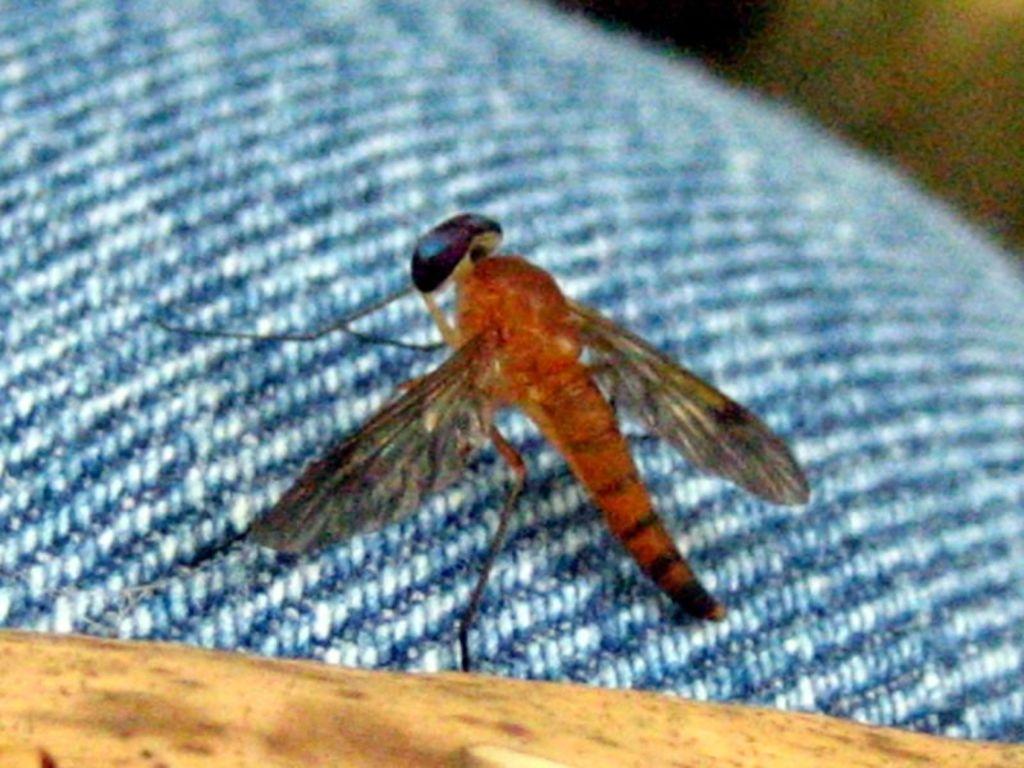In one or two sentences, can you explain what this image depicts? In this image I can see an insect on a blue color cloth. 